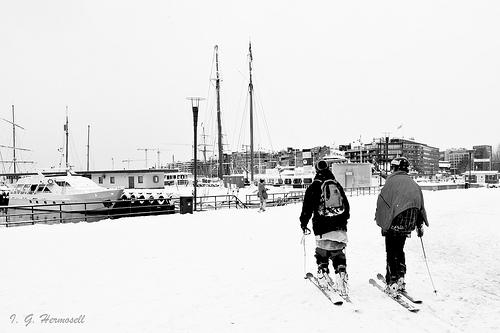In a few words, describe the environment portrayed in this image. Snowy winter landscape with a harbor, boats, and buildings. What is the primary activity taking place in this image? Two people are skiing towards the harbor in a snowy winter scene. Identify the main weather condition displayed in this image. The main weather condition is cold, snowy, and grey. What type of transportation is visible in the water near the pier? There are boats in the water near the pier, including a sailboat and a white boat parked at a dock. Count the number of people on skis in this image. There are two people on skis in the image. What are the people wearing while skiing in this snowy environment? Both people are wearing hats and coats; one person is also wearing a backpack and a helmet. Provide a brief summary of the scene captured in the photograph. In the image, two individuals are skiing in a winter landscape with snow-covered ground, a harbor and boats in the background, and buildings in the distance. Are the persons on skis wearing shorts instead of pants? No, it's not mentioned in the image. Can you see a colorful rainbow over the boat house on the pier? The image is described as a black and white photo, which implies that there are no colors, and certainly no rainbows in the image. Are the boats in the water surrounded by palm trees? The image is described as a winter scene with cold water and snow; there is no mention of palm trees, which would suggest a tropical setting. Is the sky bright and sunny in the picture? The image is described as having a cold grey sky during winter, which is the opposite of bright and sunny. 